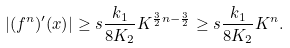Convert formula to latex. <formula><loc_0><loc_0><loc_500><loc_500>| ( f ^ { n } ) ^ { \prime } ( x ) | \geq s \frac { k _ { 1 } } { 8 K _ { 2 } } K ^ { \frac { 3 } { 2 } n - \frac { 3 } { 2 } } \geq s \frac { k _ { 1 } } { 8 K _ { 2 } } K ^ { n } .</formula> 